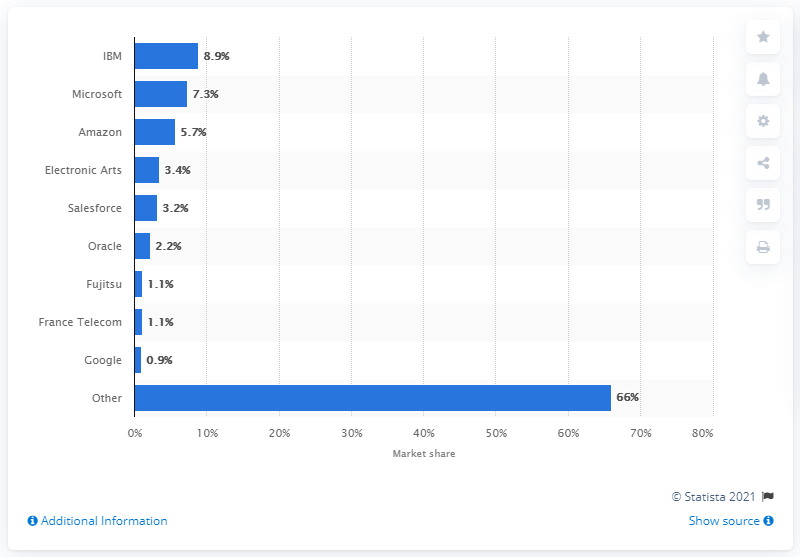Mention a couple of crucial points in this snapshot. In 2015, IBM was the largest cloud vendor in the EMEA region. 